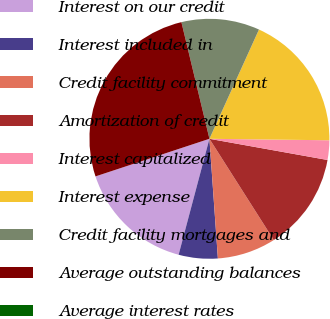<chart> <loc_0><loc_0><loc_500><loc_500><pie_chart><fcel>Interest on our credit<fcel>Interest included in<fcel>Credit facility commitment<fcel>Amortization of credit<fcel>Interest capitalized<fcel>Interest expense<fcel>Credit facility mortgages and<fcel>Average outstanding balances<fcel>Average interest rates<nl><fcel>15.79%<fcel>5.26%<fcel>7.89%<fcel>13.16%<fcel>2.63%<fcel>18.42%<fcel>10.53%<fcel>26.32%<fcel>0.0%<nl></chart> 